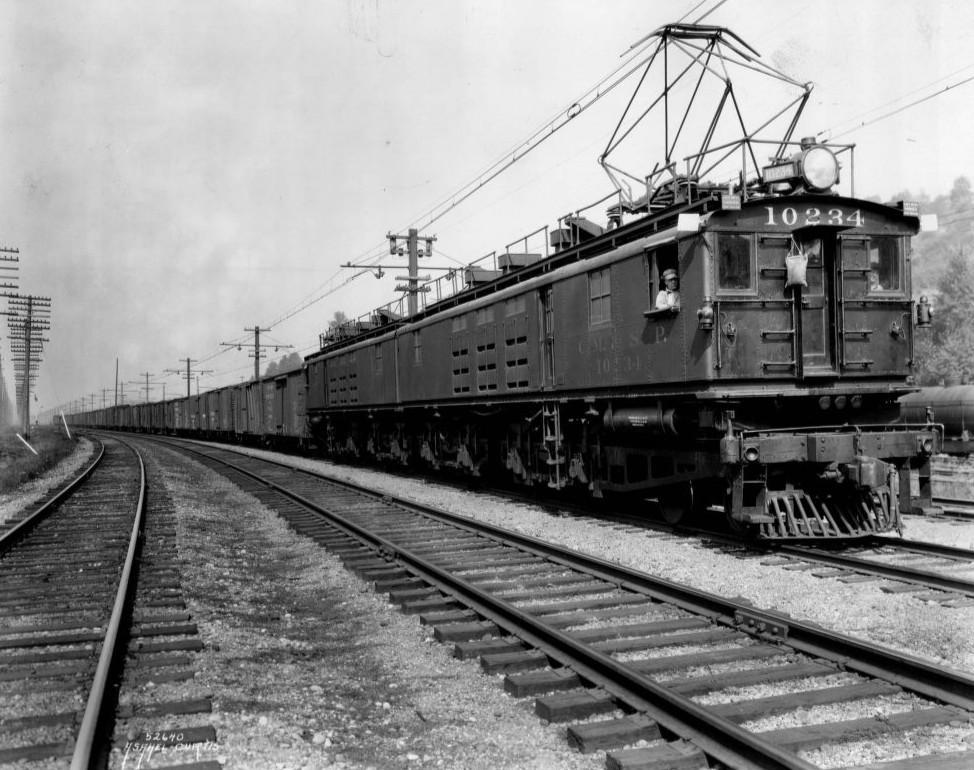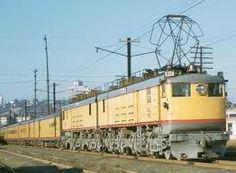The first image is the image on the left, the second image is the image on the right. Assess this claim about the two images: "Two trains are angled in different directions.". Correct or not? Answer yes or no. No. The first image is the image on the left, the second image is the image on the right. Considering the images on both sides, is "there are no power poles in the image on the right" valid? Answer yes or no. No. 